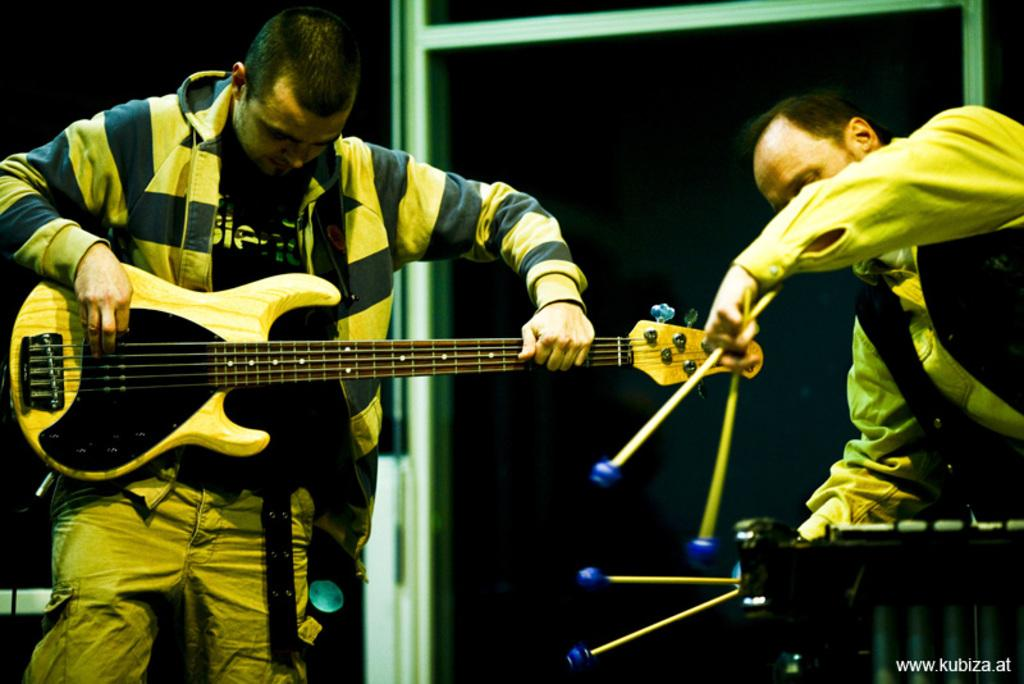How many people are in the image? There are two persons in the image. What are the persons doing in the image? The persons are playing a musical instrument. Can you describe anything in the background of the image? Yes, there is a rod visible in the background of the image. What type of coal is being used to fuel the expansion in the image? There is no coal or expansion present in the image; it features two persons playing a musical instrument with a rod visible in the background. 